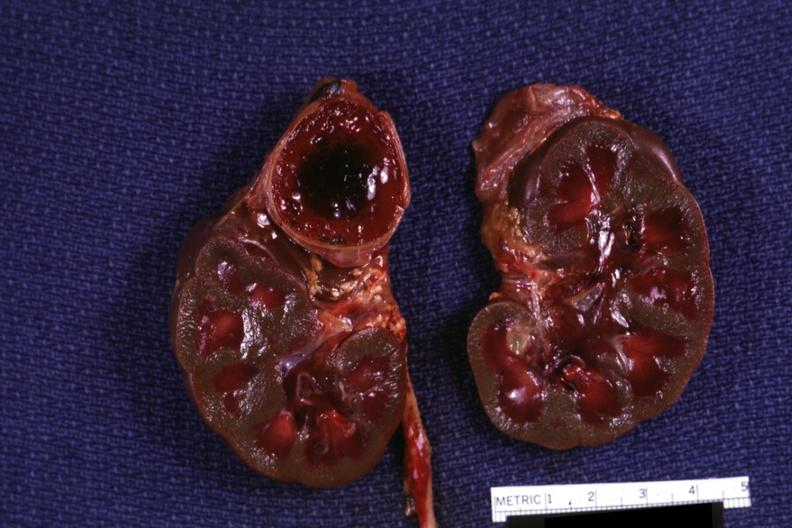what is present?
Answer the question using a single word or phrase. Endocrine 